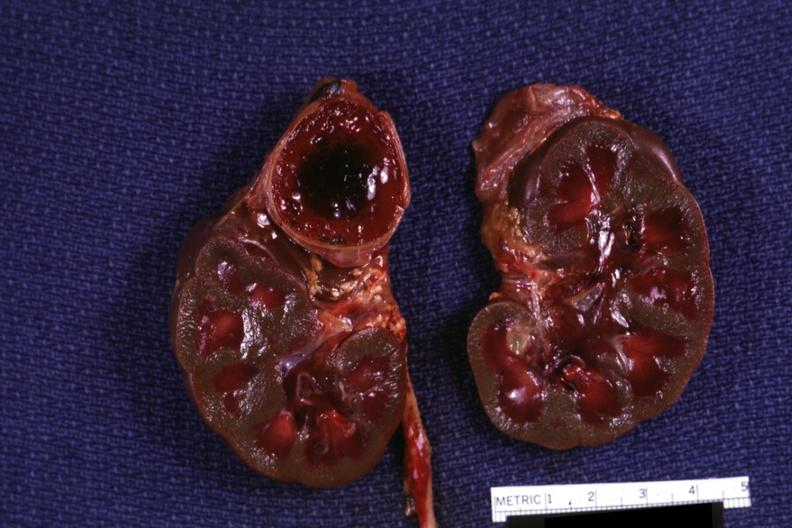what is present?
Answer the question using a single word or phrase. Endocrine 